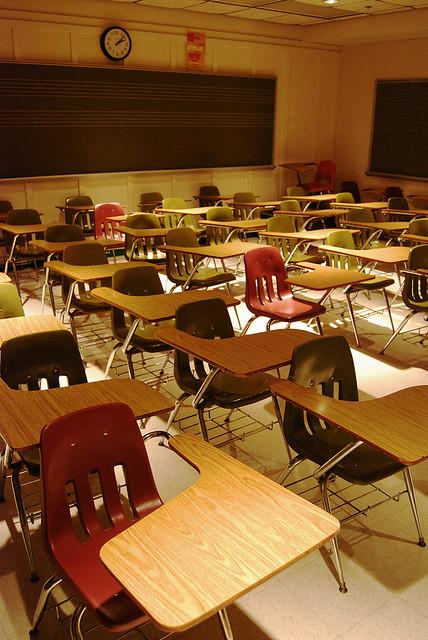Where is the clock?
Short answer required. Wall. Is the classroom used for learning?
Short answer required. Yes. How many left handed desks are clearly visible?
Answer briefly. 2. 